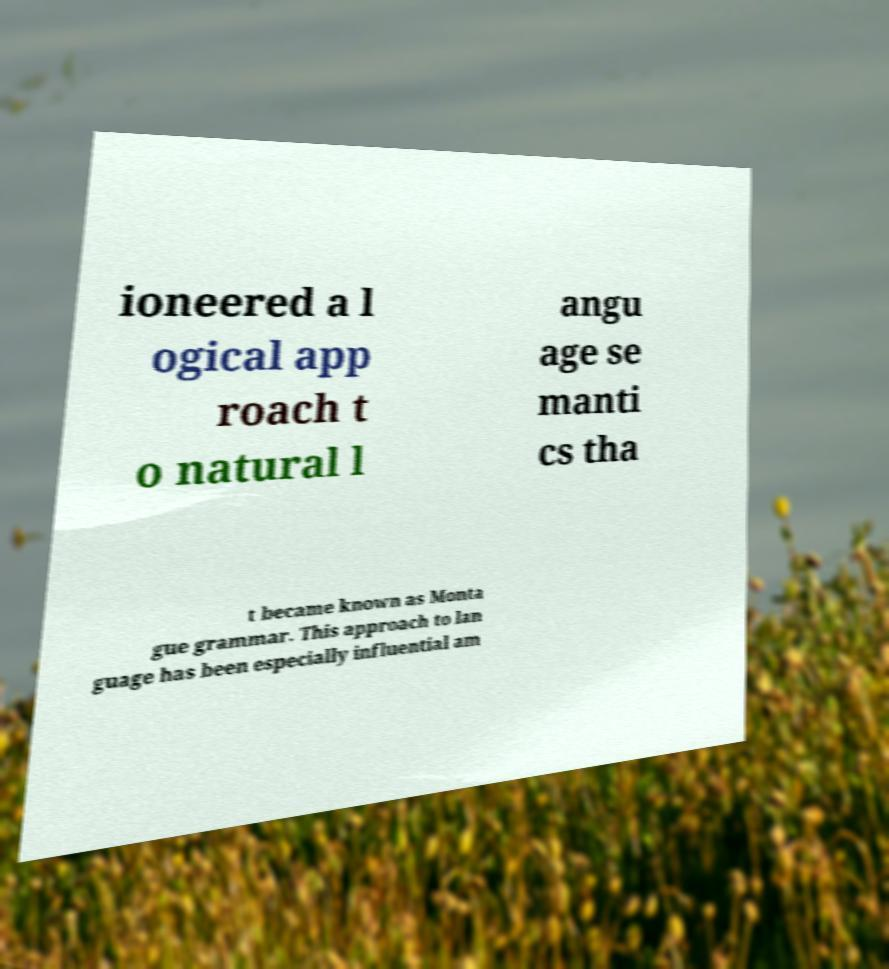For documentation purposes, I need the text within this image transcribed. Could you provide that? ioneered a l ogical app roach t o natural l angu age se manti cs tha t became known as Monta gue grammar. This approach to lan guage has been especially influential am 